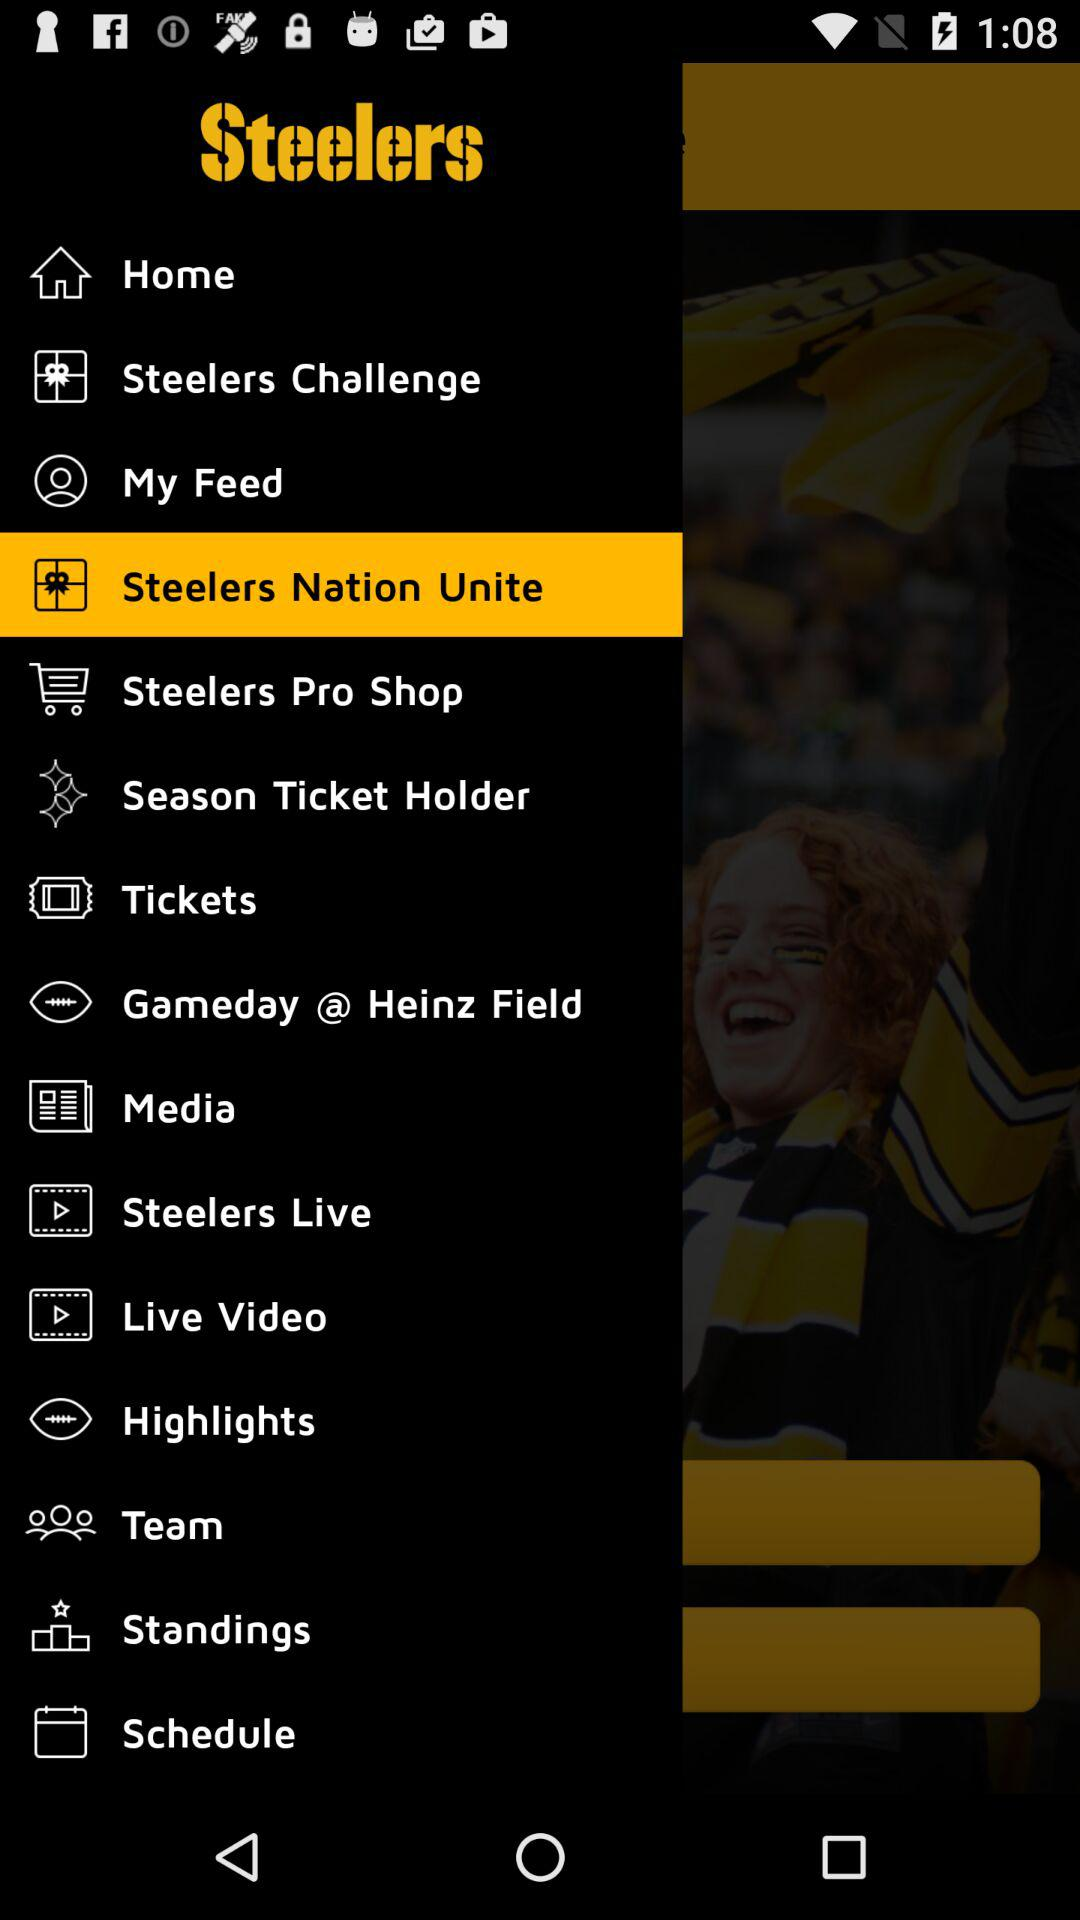Which item is selected? The item "Steelers Nation Unite" is selected. 